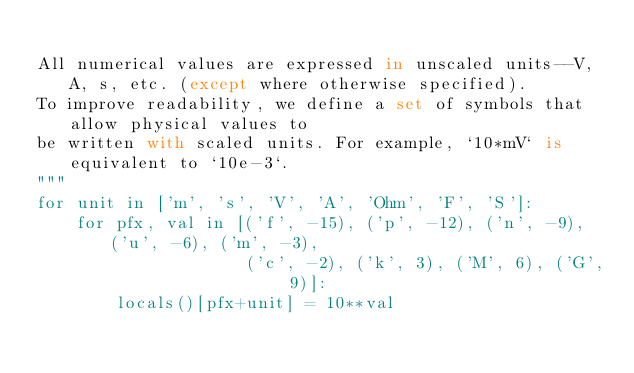<code> <loc_0><loc_0><loc_500><loc_500><_Python_>
All numerical values are expressed in unscaled units--V, A, s, etc. (except where otherwise specified).
To improve readability, we define a set of symbols that allow physical values to
be written with scaled units. For example, `10*mV` is equivalent to `10e-3`.
"""
for unit in ['m', 's', 'V', 'A', 'Ohm', 'F', 'S']:
    for pfx, val in [('f', -15), ('p', -12), ('n', -9), ('u', -6), ('m', -3), 
                     ('c', -2), ('k', 3), ('M', 6), ('G', 9)]:
        locals()[pfx+unit] = 10**val
</code> 